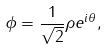<formula> <loc_0><loc_0><loc_500><loc_500>\phi = \frac { 1 } { \sqrt { 2 } } \rho e ^ { i \theta } ,</formula> 